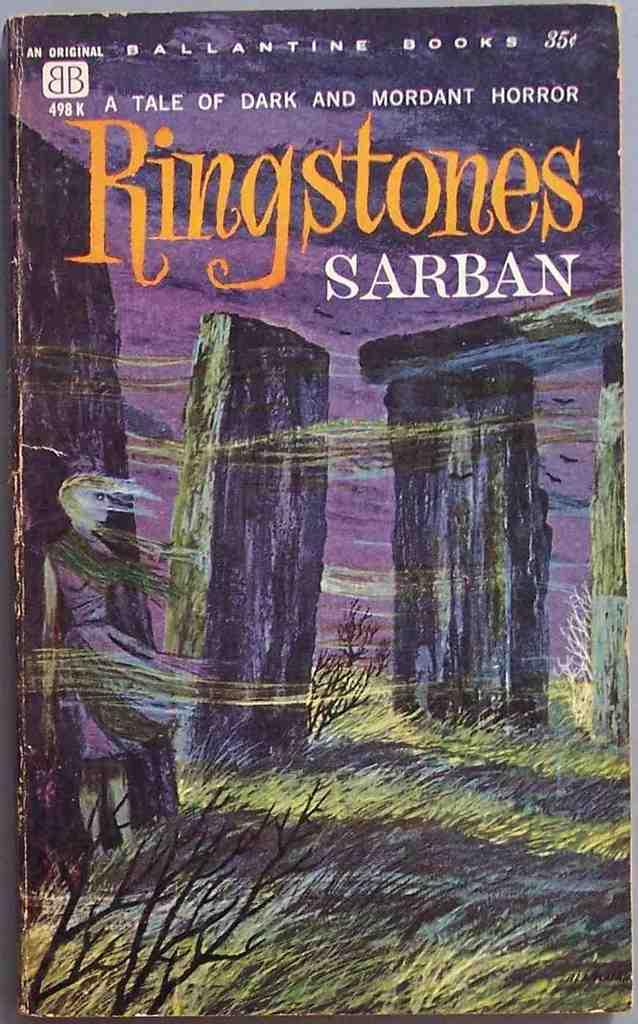Provide a one-sentence caption for the provided image. the name ringstones that is on a book. 